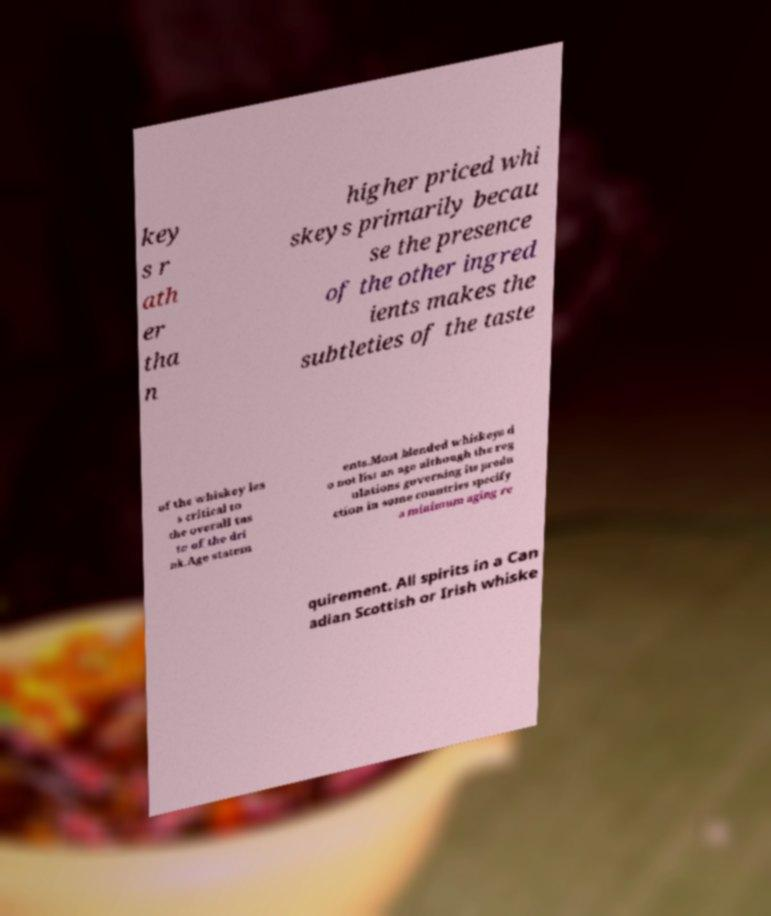There's text embedded in this image that I need extracted. Can you transcribe it verbatim? key s r ath er tha n higher priced whi skeys primarily becau se the presence of the other ingred ients makes the subtleties of the taste of the whiskey les s critical to the overall tas te of the dri nk.Age statem ents.Most blended whiskeys d o not list an age although the reg ulations governing its produ ction in some countries specify a minimum aging re quirement. All spirits in a Can adian Scottish or Irish whiske 